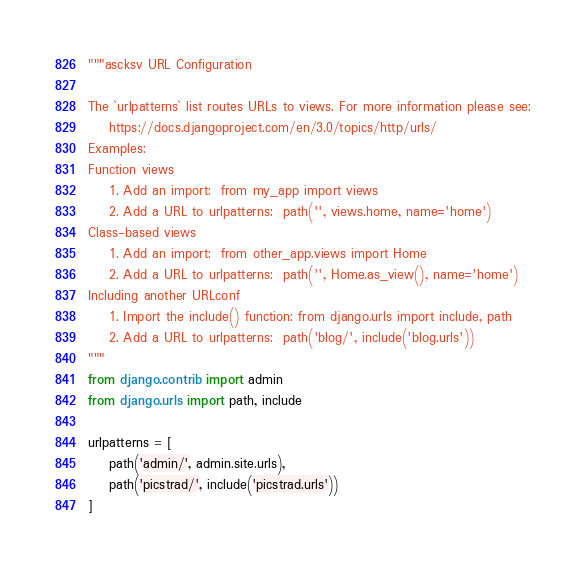Convert code to text. <code><loc_0><loc_0><loc_500><loc_500><_Python_>"""ascksv URL Configuration

The `urlpatterns` list routes URLs to views. For more information please see:
    https://docs.djangoproject.com/en/3.0/topics/http/urls/
Examples:
Function views
    1. Add an import:  from my_app import views
    2. Add a URL to urlpatterns:  path('', views.home, name='home')
Class-based views
    1. Add an import:  from other_app.views import Home
    2. Add a URL to urlpatterns:  path('', Home.as_view(), name='home')
Including another URLconf
    1. Import the include() function: from django.urls import include, path
    2. Add a URL to urlpatterns:  path('blog/', include('blog.urls'))
"""
from django.contrib import admin
from django.urls import path, include

urlpatterns = [
    path('admin/', admin.site.urls),
    path('picstrad/', include('picstrad.urls'))
]</code> 